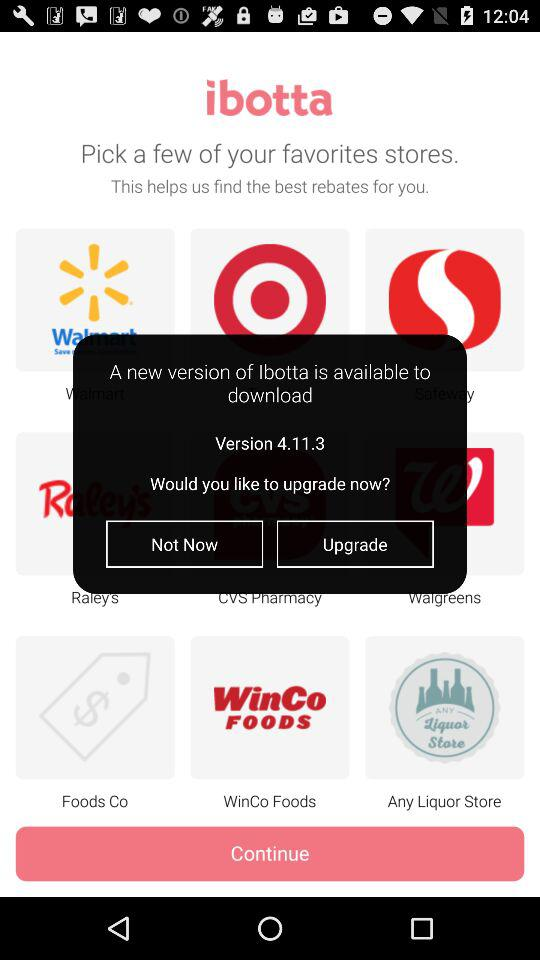Which version is available now? The available version is 4.11.3. 